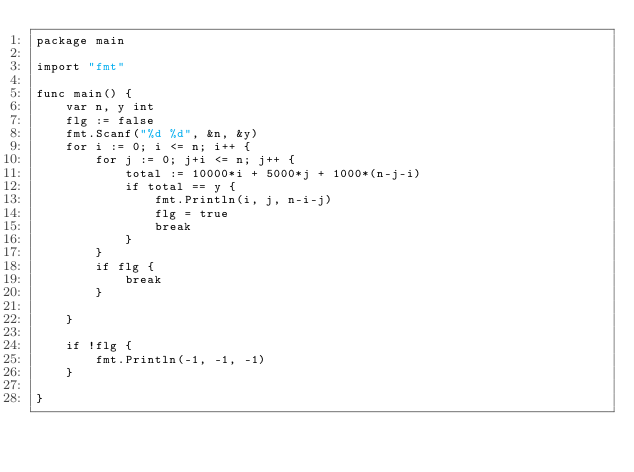<code> <loc_0><loc_0><loc_500><loc_500><_Go_>package main

import "fmt"

func main() {
	var n, y int
	flg := false
	fmt.Scanf("%d %d", &n, &y)
	for i := 0; i <= n; i++ {
		for j := 0; j+i <= n; j++ {
			total := 10000*i + 5000*j + 1000*(n-j-i)
			if total == y {
				fmt.Println(i, j, n-i-j)
				flg = true
				break
			}
		}
		if flg {
			break
		}

	}

	if !flg {
		fmt.Println(-1, -1, -1)
	}

}
</code> 